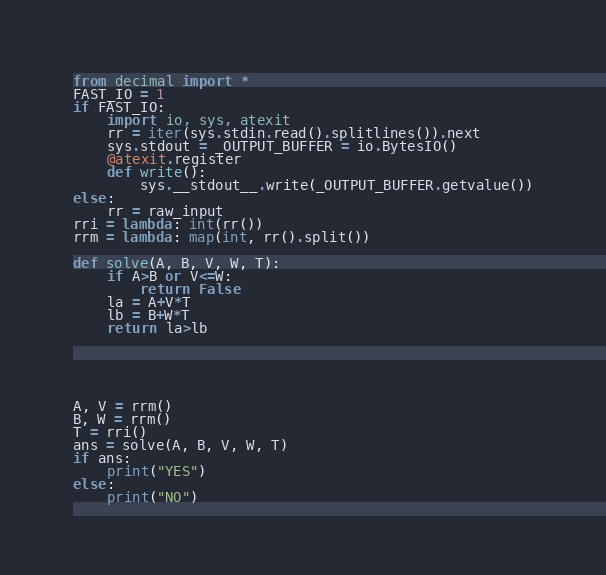Convert code to text. <code><loc_0><loc_0><loc_500><loc_500><_Python_>from decimal import *
FAST_IO = 1
if FAST_IO:
    import io, sys, atexit
    rr = iter(sys.stdin.read().splitlines()).next
    sys.stdout = _OUTPUT_BUFFER = io.BytesIO()
    @atexit.register
    def write():
        sys.__stdout__.write(_OUTPUT_BUFFER.getvalue())
else:
    rr = raw_input
rri = lambda: int(rr())
rrm = lambda: map(int, rr().split())

def solve(A, B, V, W, T):
    if A>B or V<=W:
        return False
    la = A+V*T
    lb = B+W*T
    return la>lb





A, V = rrm()
B, W = rrm()
T = rri()
ans = solve(A, B, V, W, T)
if ans:
    print("YES")
else:
    print("NO")
</code> 